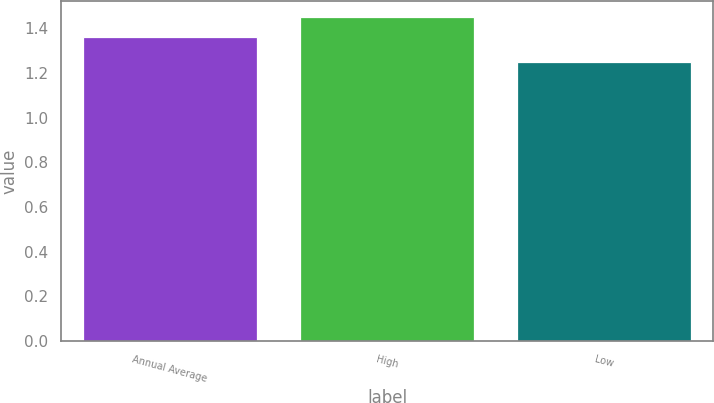Convert chart to OTSL. <chart><loc_0><loc_0><loc_500><loc_500><bar_chart><fcel>Annual Average<fcel>High<fcel>Low<nl><fcel>1.36<fcel>1.45<fcel>1.25<nl></chart> 